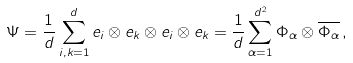<formula> <loc_0><loc_0><loc_500><loc_500>\Psi = \frac { 1 } { d } \sum _ { i , k = 1 } ^ { d } e _ { i } \otimes e _ { k } \otimes e _ { i } \otimes e _ { k } = \frac { 1 } { d } \sum _ { \alpha = 1 } ^ { d ^ { 2 } } \Phi _ { \alpha } \otimes \overline { \Phi _ { \alpha } } \, ,</formula> 